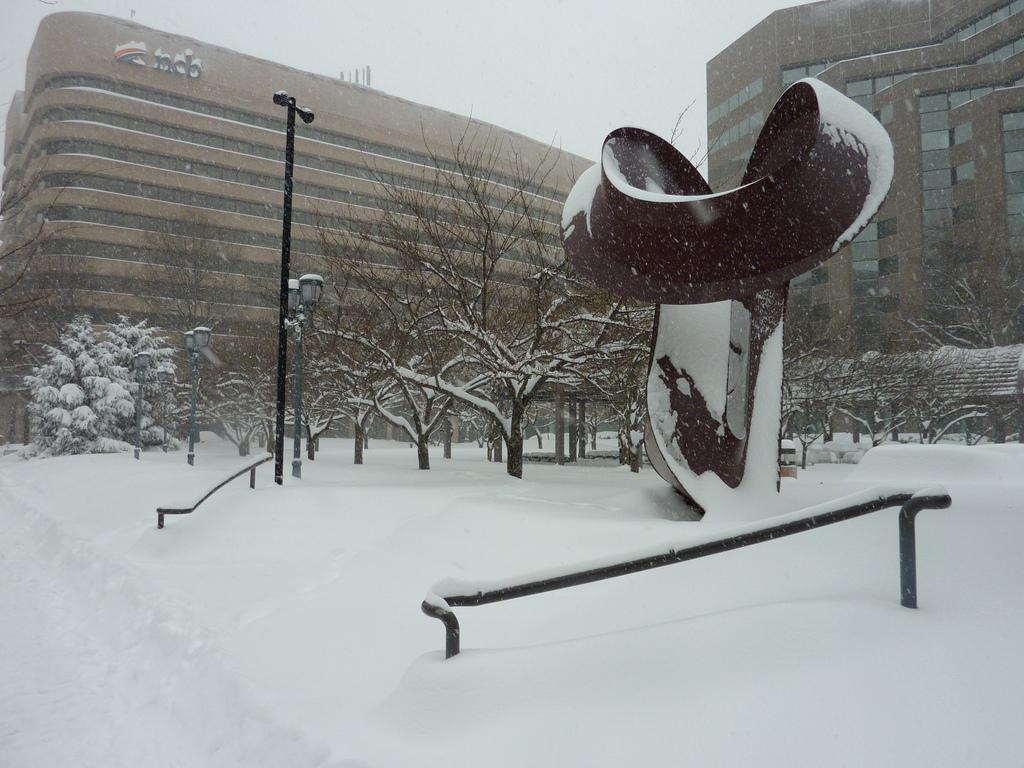In one or two sentences, can you explain what this image depicts? In this picture we can see snow at the bottom, there are some trees, poles, lights and a statue in the middle, in the background there are buildings, we can see the sky at the top of the picture. 